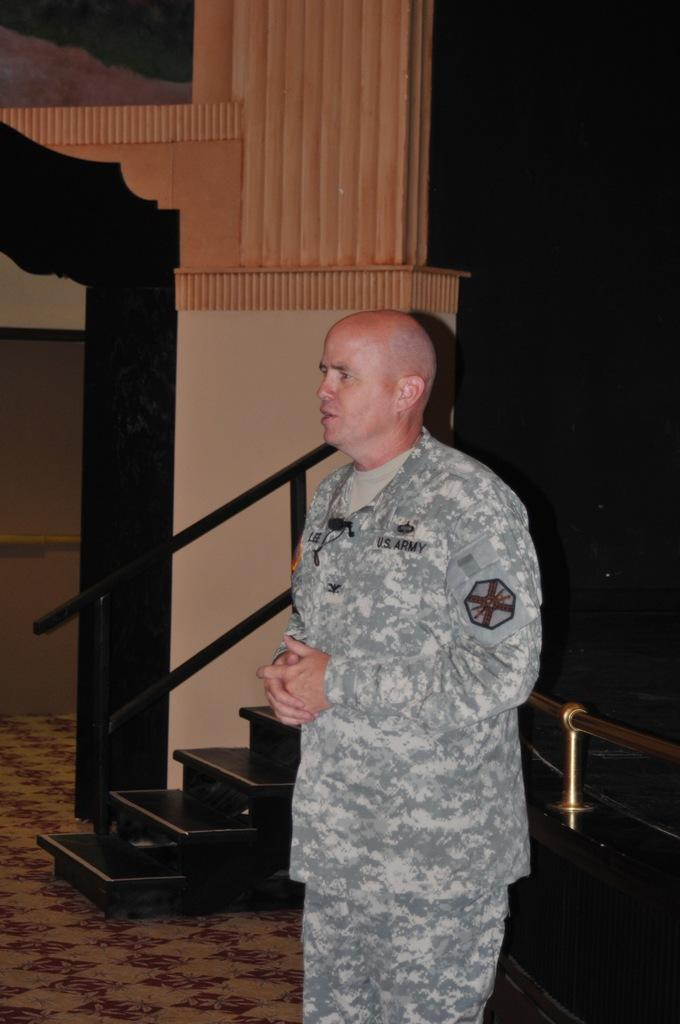What is the main subject of the image? The main subject of the image is a man. What is the man doing in the image? The man is standing in the image. What type of objects can be seen in the image besides the man? There are metal rods visible in the image. What type of underwear is the judge wearing in the image? There is no judge or underwear present in the image; it features a man standing and metal rods. Is the man in the image wearing a skate as a hat? There is no skate present in the image, and the man's headwear is not mentioned in the provided facts. 